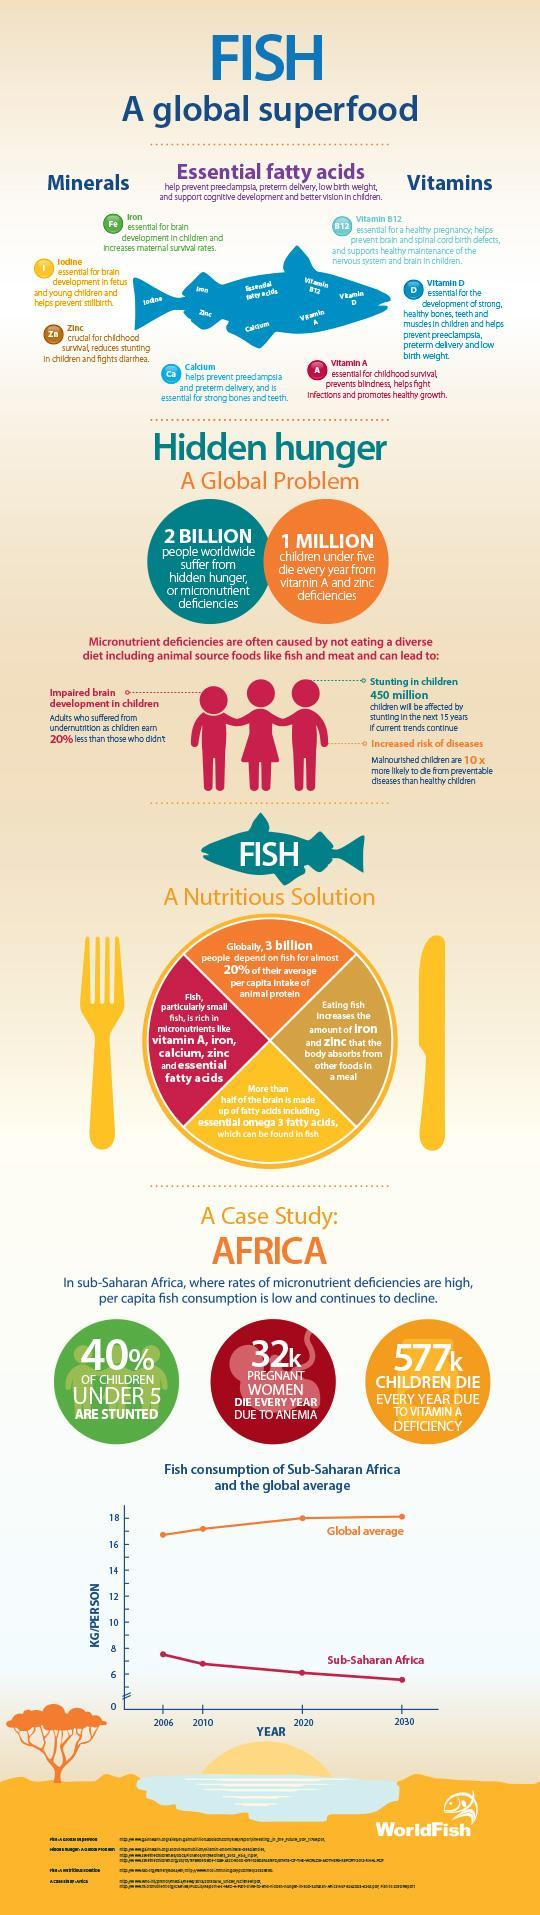What amount of children suffer from Vitamin A deficiencies, 2 billion, 3 billion, or 1 billion  ?
Answer the question with a short phrase. 1 billion How many essential minerals are found in a fish? 4 Which essential vitamins are found in a fish? A, D, B12 